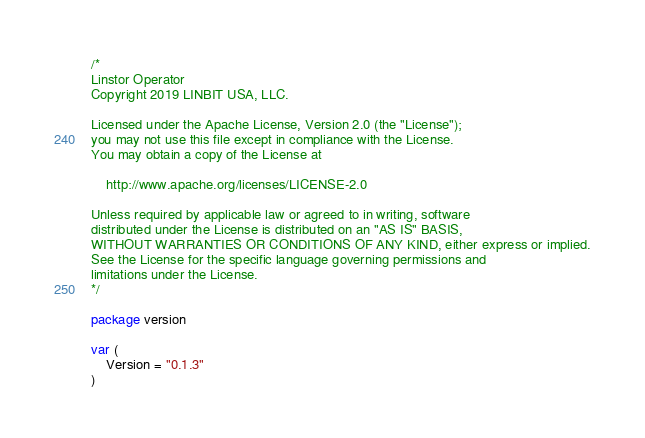<code> <loc_0><loc_0><loc_500><loc_500><_Go_>/*
Linstor Operator
Copyright 2019 LINBIT USA, LLC.

Licensed under the Apache License, Version 2.0 (the "License");
you may not use this file except in compliance with the License.
You may obtain a copy of the License at

	http://www.apache.org/licenses/LICENSE-2.0

Unless required by applicable law or agreed to in writing, software
distributed under the License is distributed on an "AS IS" BASIS,
WITHOUT WARRANTIES OR CONDITIONS OF ANY KIND, either express or implied.
See the License for the specific language governing permissions and
limitations under the License.
*/

package version

var (
	Version = "0.1.3"
)
</code> 